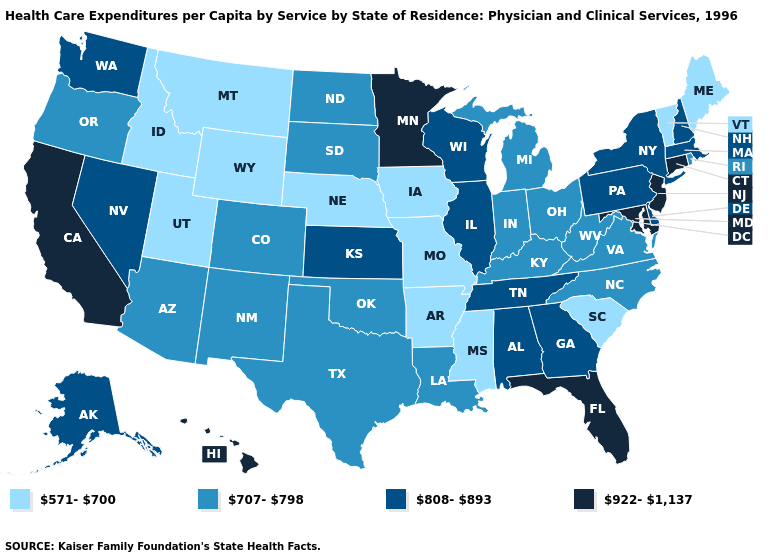Name the states that have a value in the range 707-798?
Be succinct. Arizona, Colorado, Indiana, Kentucky, Louisiana, Michigan, New Mexico, North Carolina, North Dakota, Ohio, Oklahoma, Oregon, Rhode Island, South Dakota, Texas, Virginia, West Virginia. Does New York have the lowest value in the Northeast?
Give a very brief answer. No. Does the first symbol in the legend represent the smallest category?
Concise answer only. Yes. What is the value of Minnesota?
Short answer required. 922-1,137. What is the lowest value in the USA?
Give a very brief answer. 571-700. Name the states that have a value in the range 571-700?
Be succinct. Arkansas, Idaho, Iowa, Maine, Mississippi, Missouri, Montana, Nebraska, South Carolina, Utah, Vermont, Wyoming. What is the value of Arkansas?
Keep it brief. 571-700. Among the states that border Nevada , which have the highest value?
Quick response, please. California. Which states have the highest value in the USA?
Answer briefly. California, Connecticut, Florida, Hawaii, Maryland, Minnesota, New Jersey. What is the value of Indiana?
Be succinct. 707-798. Name the states that have a value in the range 808-893?
Answer briefly. Alabama, Alaska, Delaware, Georgia, Illinois, Kansas, Massachusetts, Nevada, New Hampshire, New York, Pennsylvania, Tennessee, Washington, Wisconsin. What is the value of New York?
Write a very short answer. 808-893. Is the legend a continuous bar?
Quick response, please. No. Does the map have missing data?
Give a very brief answer. No. Name the states that have a value in the range 571-700?
Short answer required. Arkansas, Idaho, Iowa, Maine, Mississippi, Missouri, Montana, Nebraska, South Carolina, Utah, Vermont, Wyoming. 